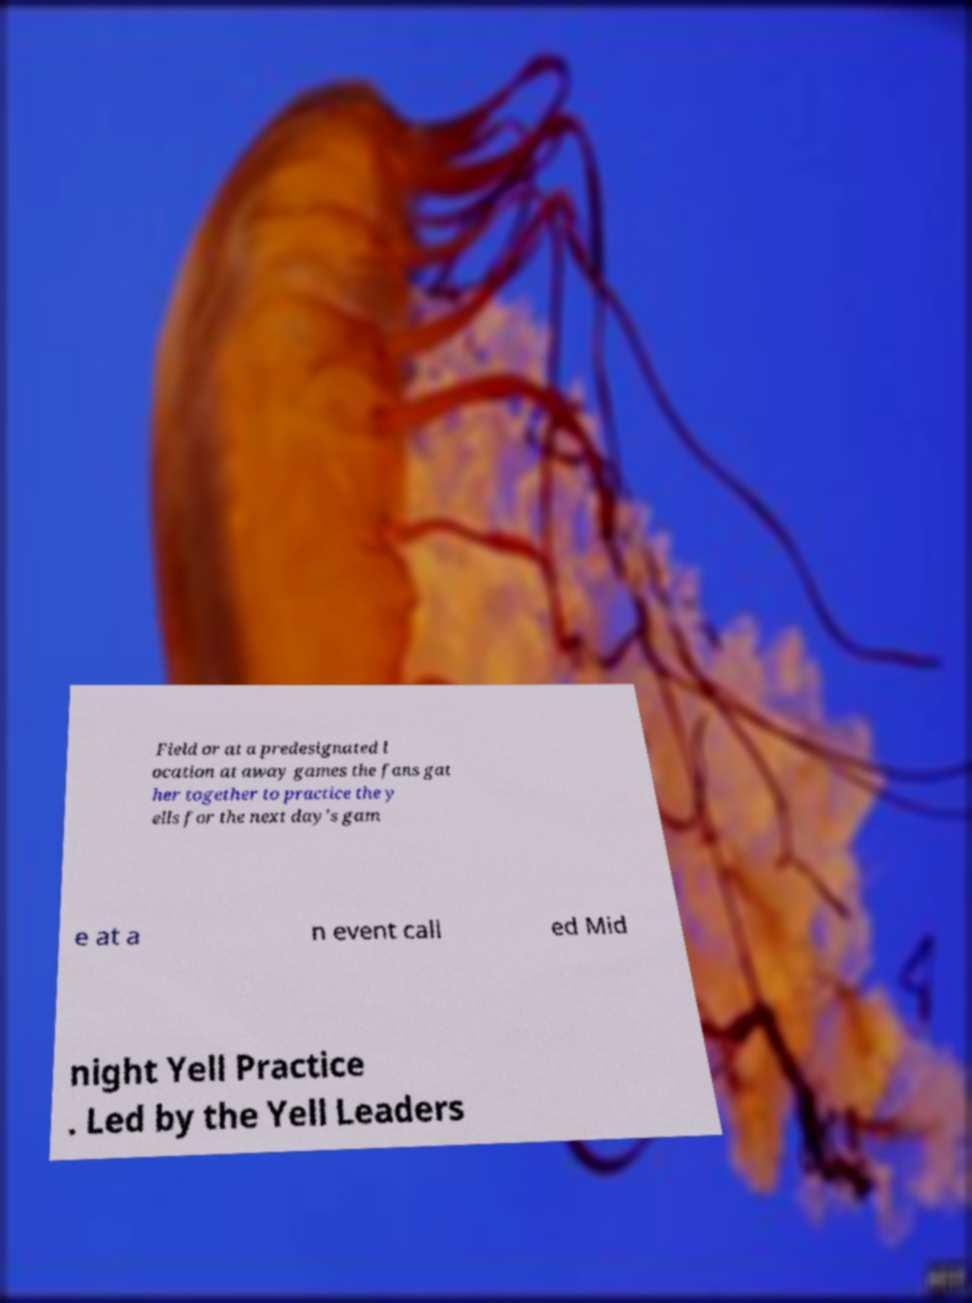For documentation purposes, I need the text within this image transcribed. Could you provide that? Field or at a predesignated l ocation at away games the fans gat her together to practice the y ells for the next day's gam e at a n event call ed Mid night Yell Practice . Led by the Yell Leaders 